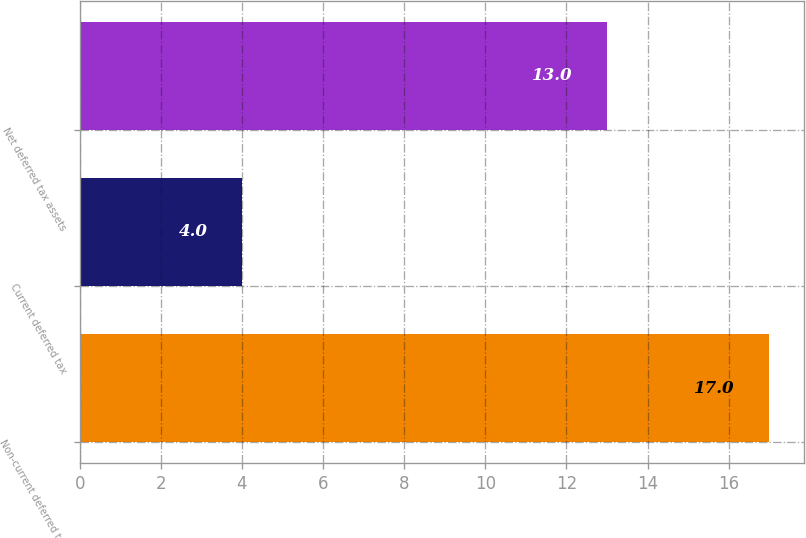Convert chart. <chart><loc_0><loc_0><loc_500><loc_500><bar_chart><fcel>Non-current deferred tax<fcel>Current deferred tax<fcel>Net deferred tax assets<nl><fcel>17<fcel>4<fcel>13<nl></chart> 